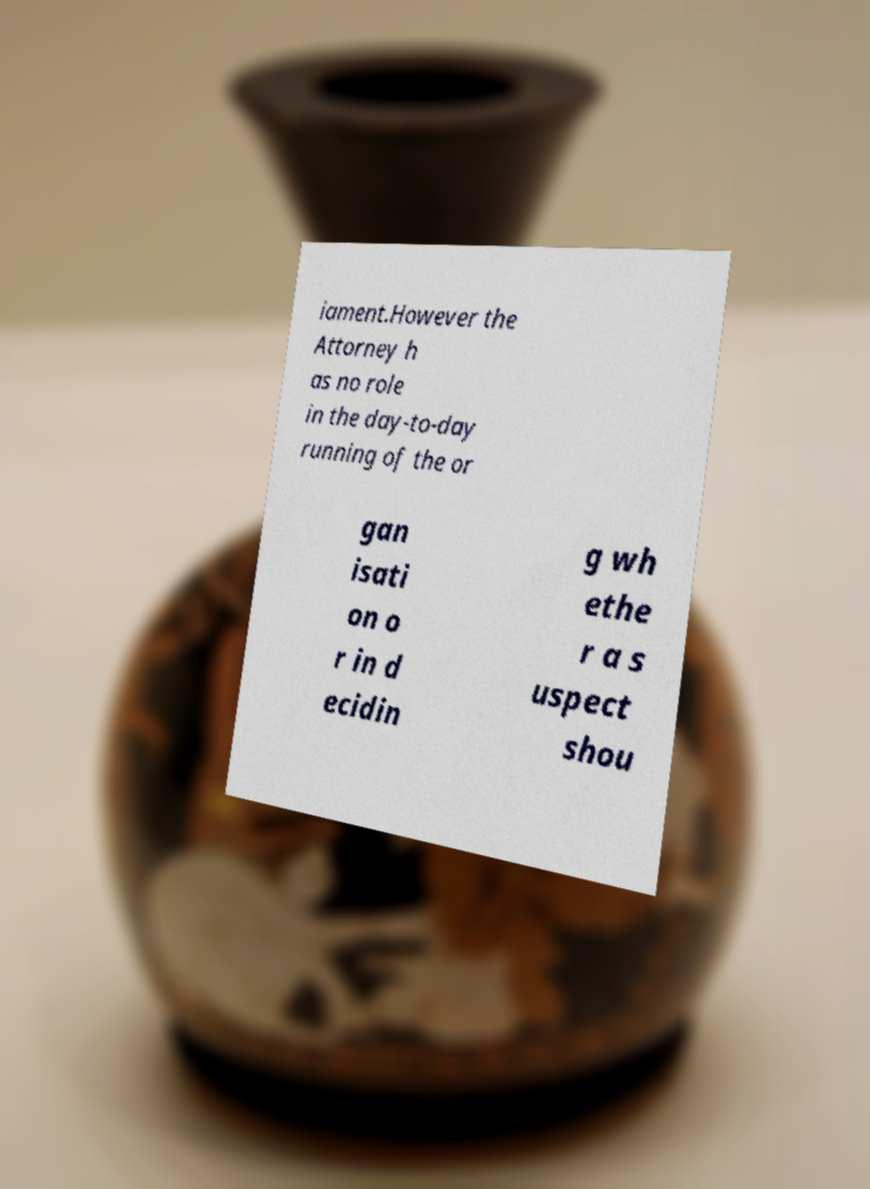I need the written content from this picture converted into text. Can you do that? iament.However the Attorney h as no role in the day-to-day running of the or gan isati on o r in d ecidin g wh ethe r a s uspect shou 